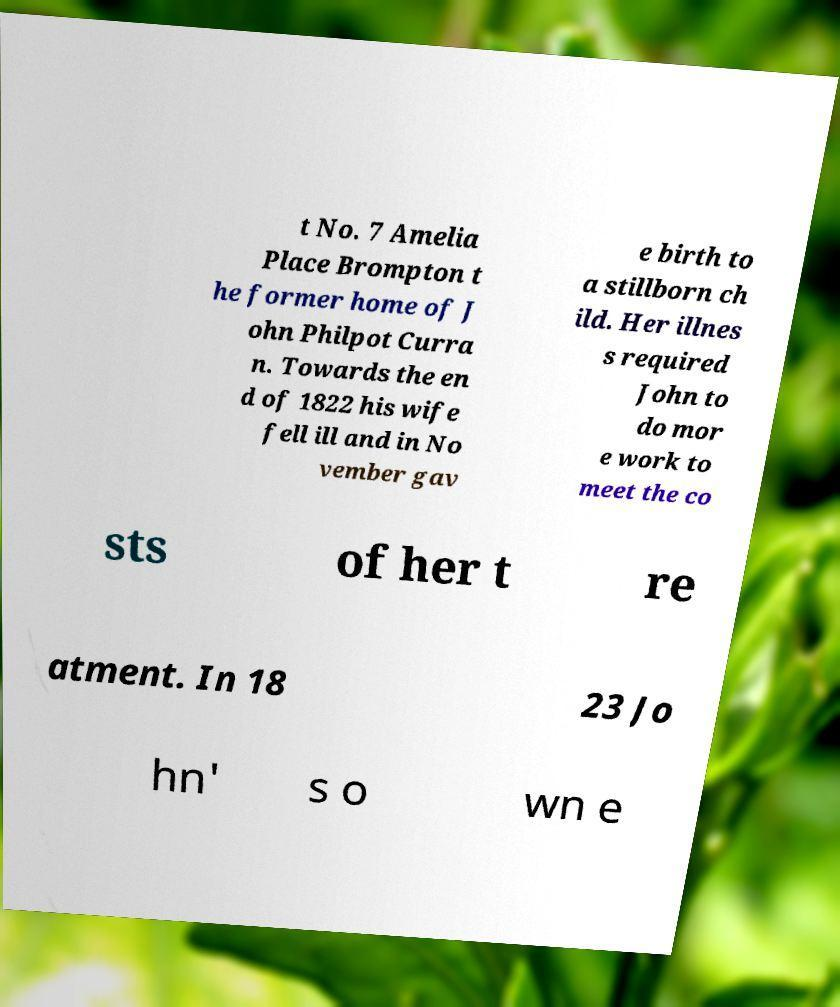Can you accurately transcribe the text from the provided image for me? t No. 7 Amelia Place Brompton t he former home of J ohn Philpot Curra n. Towards the en d of 1822 his wife fell ill and in No vember gav e birth to a stillborn ch ild. Her illnes s required John to do mor e work to meet the co sts of her t re atment. In 18 23 Jo hn' s o wn e 